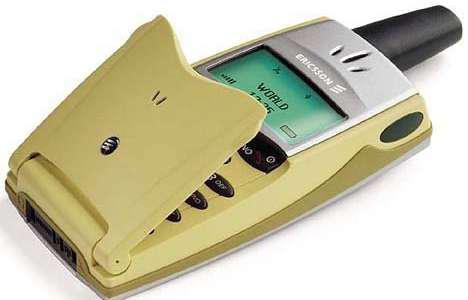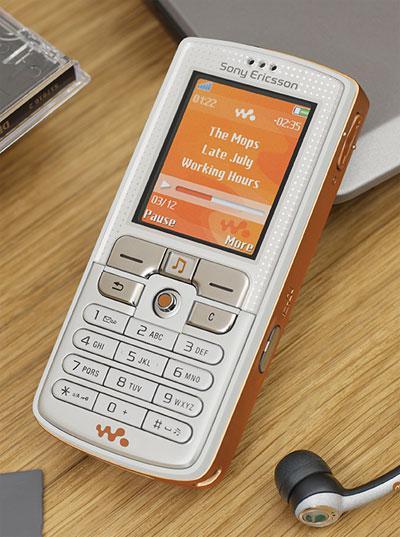The first image is the image on the left, the second image is the image on the right. Examine the images to the left and right. Is the description "One of the cell phones is yellow with a short black antenna." accurate? Answer yes or no. Yes. The first image is the image on the left, the second image is the image on the right. Analyze the images presented: Is the assertion "A yellow cellphone has a visible black antena in one of the images." valid? Answer yes or no. Yes. 